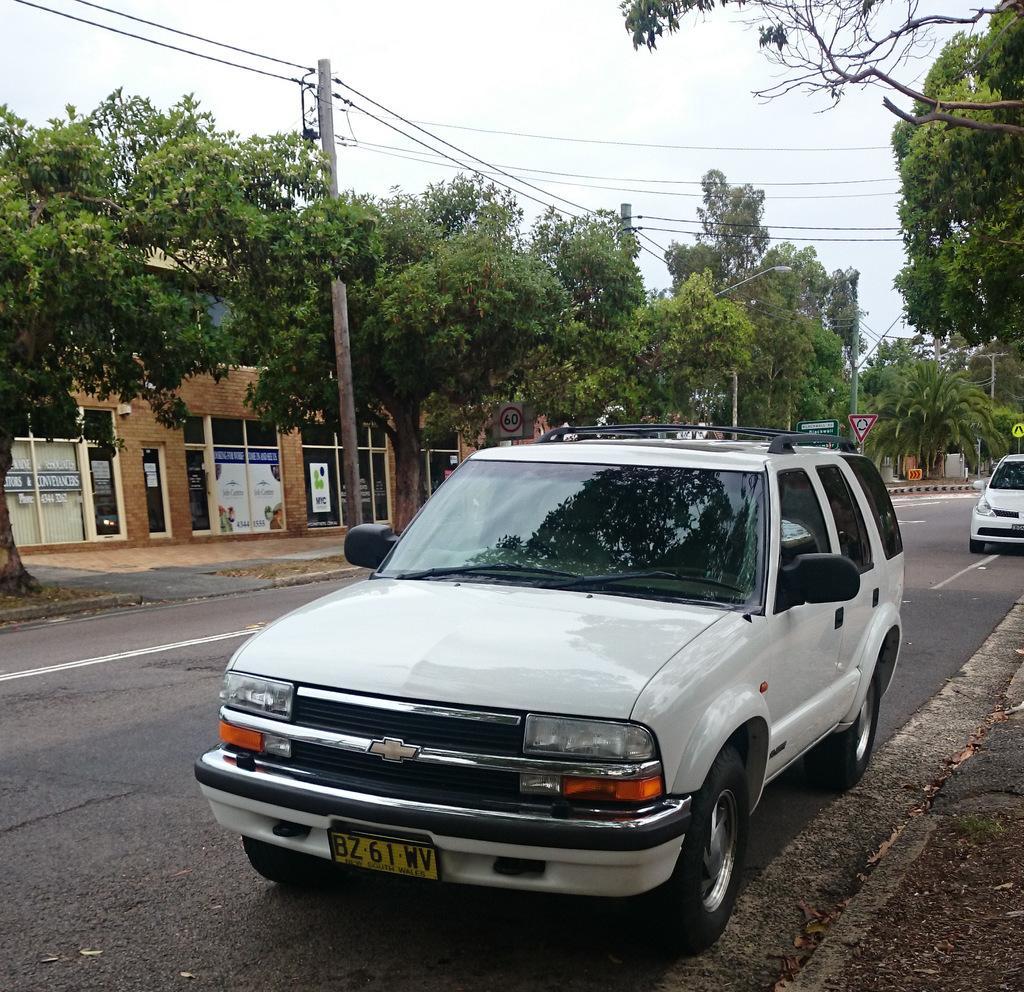Can you describe this image briefly? In this image we can see two cars on the road, there are few trees, sign boards, a pole with wires, building with posters to the glass and the sky in the background. 